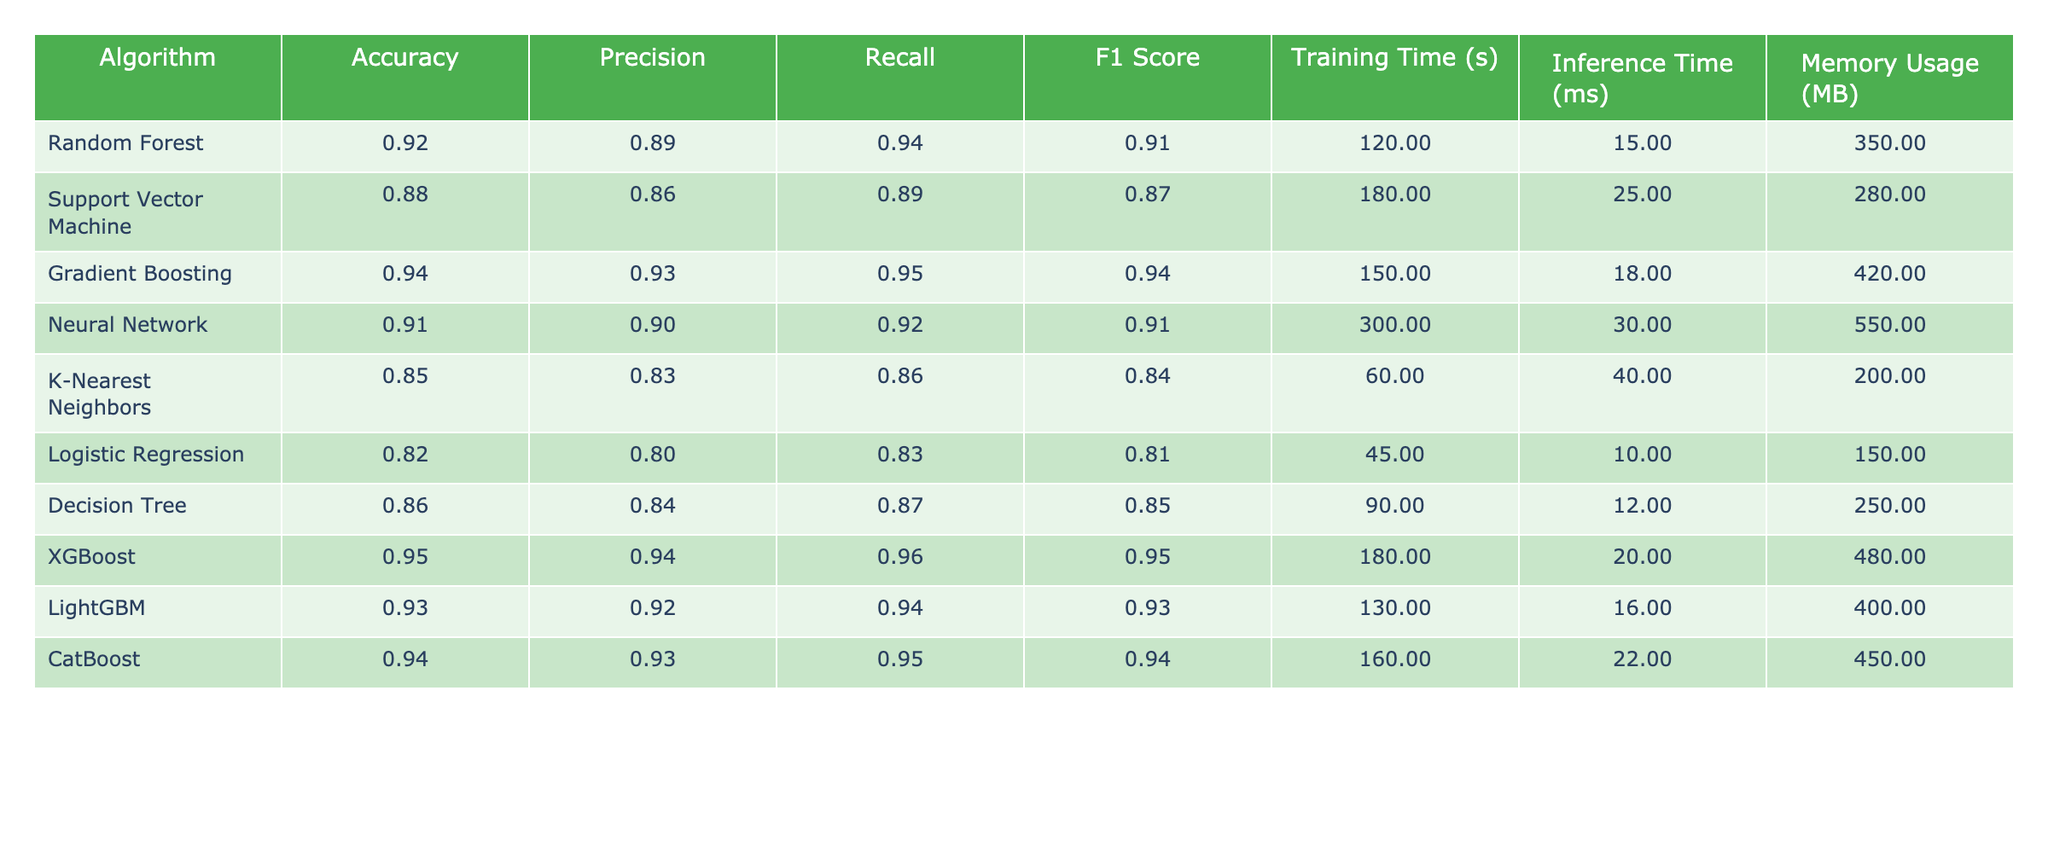What is the accuracy of the Support Vector Machine? The accuracy value for the Support Vector Machine can be directly found in the table. It is listed under the Accuracy column for that algorithm.
Answer: 0.88 Which algorithm has the highest F1 Score? To identify the algorithm with the highest F1 Score, compare the F1 Score values for all algorithms listed in the table. The highest value corresponds to the Gradient Boosting and XGBoost algorithms, both having an F1 Score of 0.95.
Answer: Gradient Boosting and XGBoost What is the average Training Time of all algorithms? First, add all the training times listed in the table: 120 + 180 + 150 + 300 + 60 + 45 + 90 + 180 + 130 + 160 = 1,365 seconds. Then, divide by the number of algorithms (10) to find the average: 1,365 / 10 = 136.5 seconds.
Answer: 136.5 seconds Does the Neural Network algorithm have a better Recall than Logistic Regression? Compare the Recall values for both the Neural Network (0.92) and Logistic Regression (0.83). Since 0.92 is greater than 0.83, the Neural Network does have a better Recall.
Answer: Yes Which algorithm has the lowest Memory Usage? By examining the Memory Usage column, find the algorithm with the smallest value. K-Nearest Neighbors has the lowest Memory Usage at 200 MB.
Answer: K-Nearest Neighbors What is the difference in Accuracy between XGBoost and K-Nearest Neighbors? First, identify the Accuracy values: XGBoost = 0.95 and K-Nearest Neighbors = 0.85. Then calculate the difference: 0.95 - 0.85 = 0.10.
Answer: 0.10 Is the Precision of the Random Forest higher than that of the Decision Tree? Look at the Precision values: Random Forest has a Precision of 0.89 while Decision Tree has 0.84. Since 0.89 is greater than 0.84, it confirms that Random Forest's Precision is indeed higher.
Answer: Yes What is the sum of Inference Times for all algorithms? Add together all the Inference Time values from the table: 15 + 25 + 18 + 30 + 40 + 10 + 12 + 20 + 16 + 22 =  288 ms.
Answer: 288 ms Which algorithm has the longest Training Time? Examine the Training Time column and determine the maximum value. The Neural Network has the longest Training Time at 300 seconds.
Answer: Neural Network Based on the metrics, should we prefer XGBoost over Support Vector Machine? Review the overall performance metrics: XGBoost achieves the highest Accuracy (0.95), Precision (0.94), Recall (0.96), and F1 Score (0.95) compared to Support Vector Machine's scores (Accuracy: 0.88, Precision: 0.86, Recall: 0.89, F1 Score: 0.87). Thus, XGBoost outperforms Support Vector Machine across multiple metrics.
Answer: Yes 